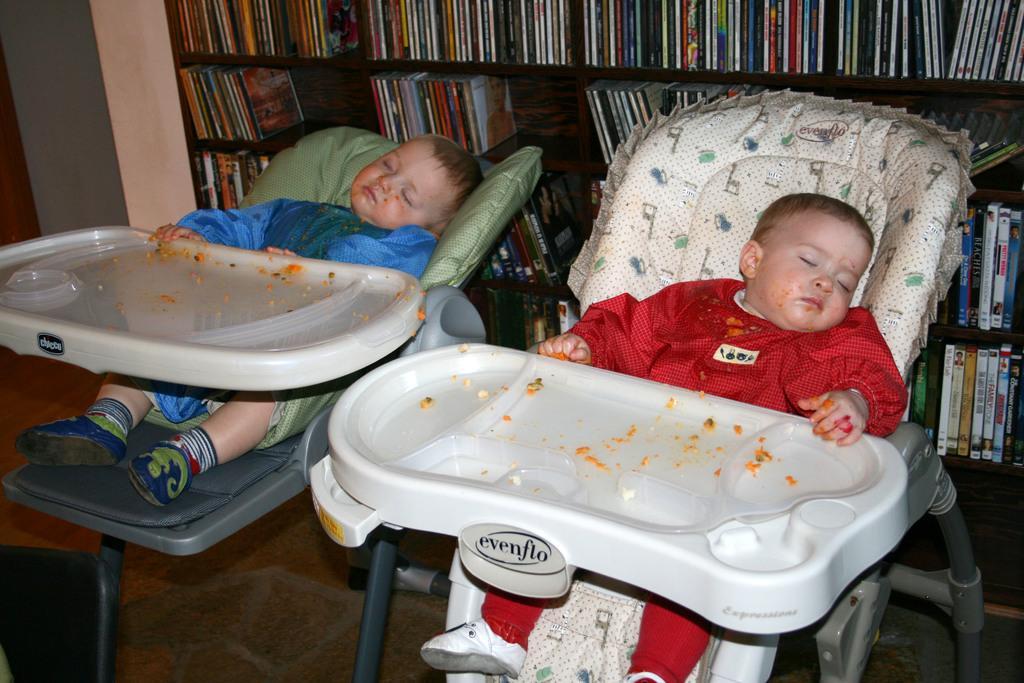Please provide a concise description of this image. In this image we can see two babies are sleeping on strollers, One is wearing red color dress and the other one is wearing blue color dress. Behind them book rack is present. 